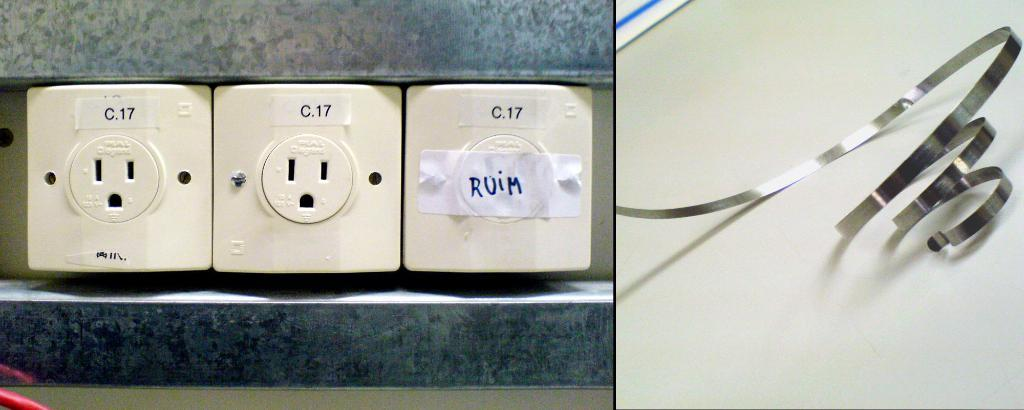What type of outlets are visible in the image? There are electric sockets in the image. What material is the strip placed on the surface in the image made of? The strip is made of metal. How many loaves of bread can be seen on the tray in the image? There is no tray or loaves of bread present in the image. 